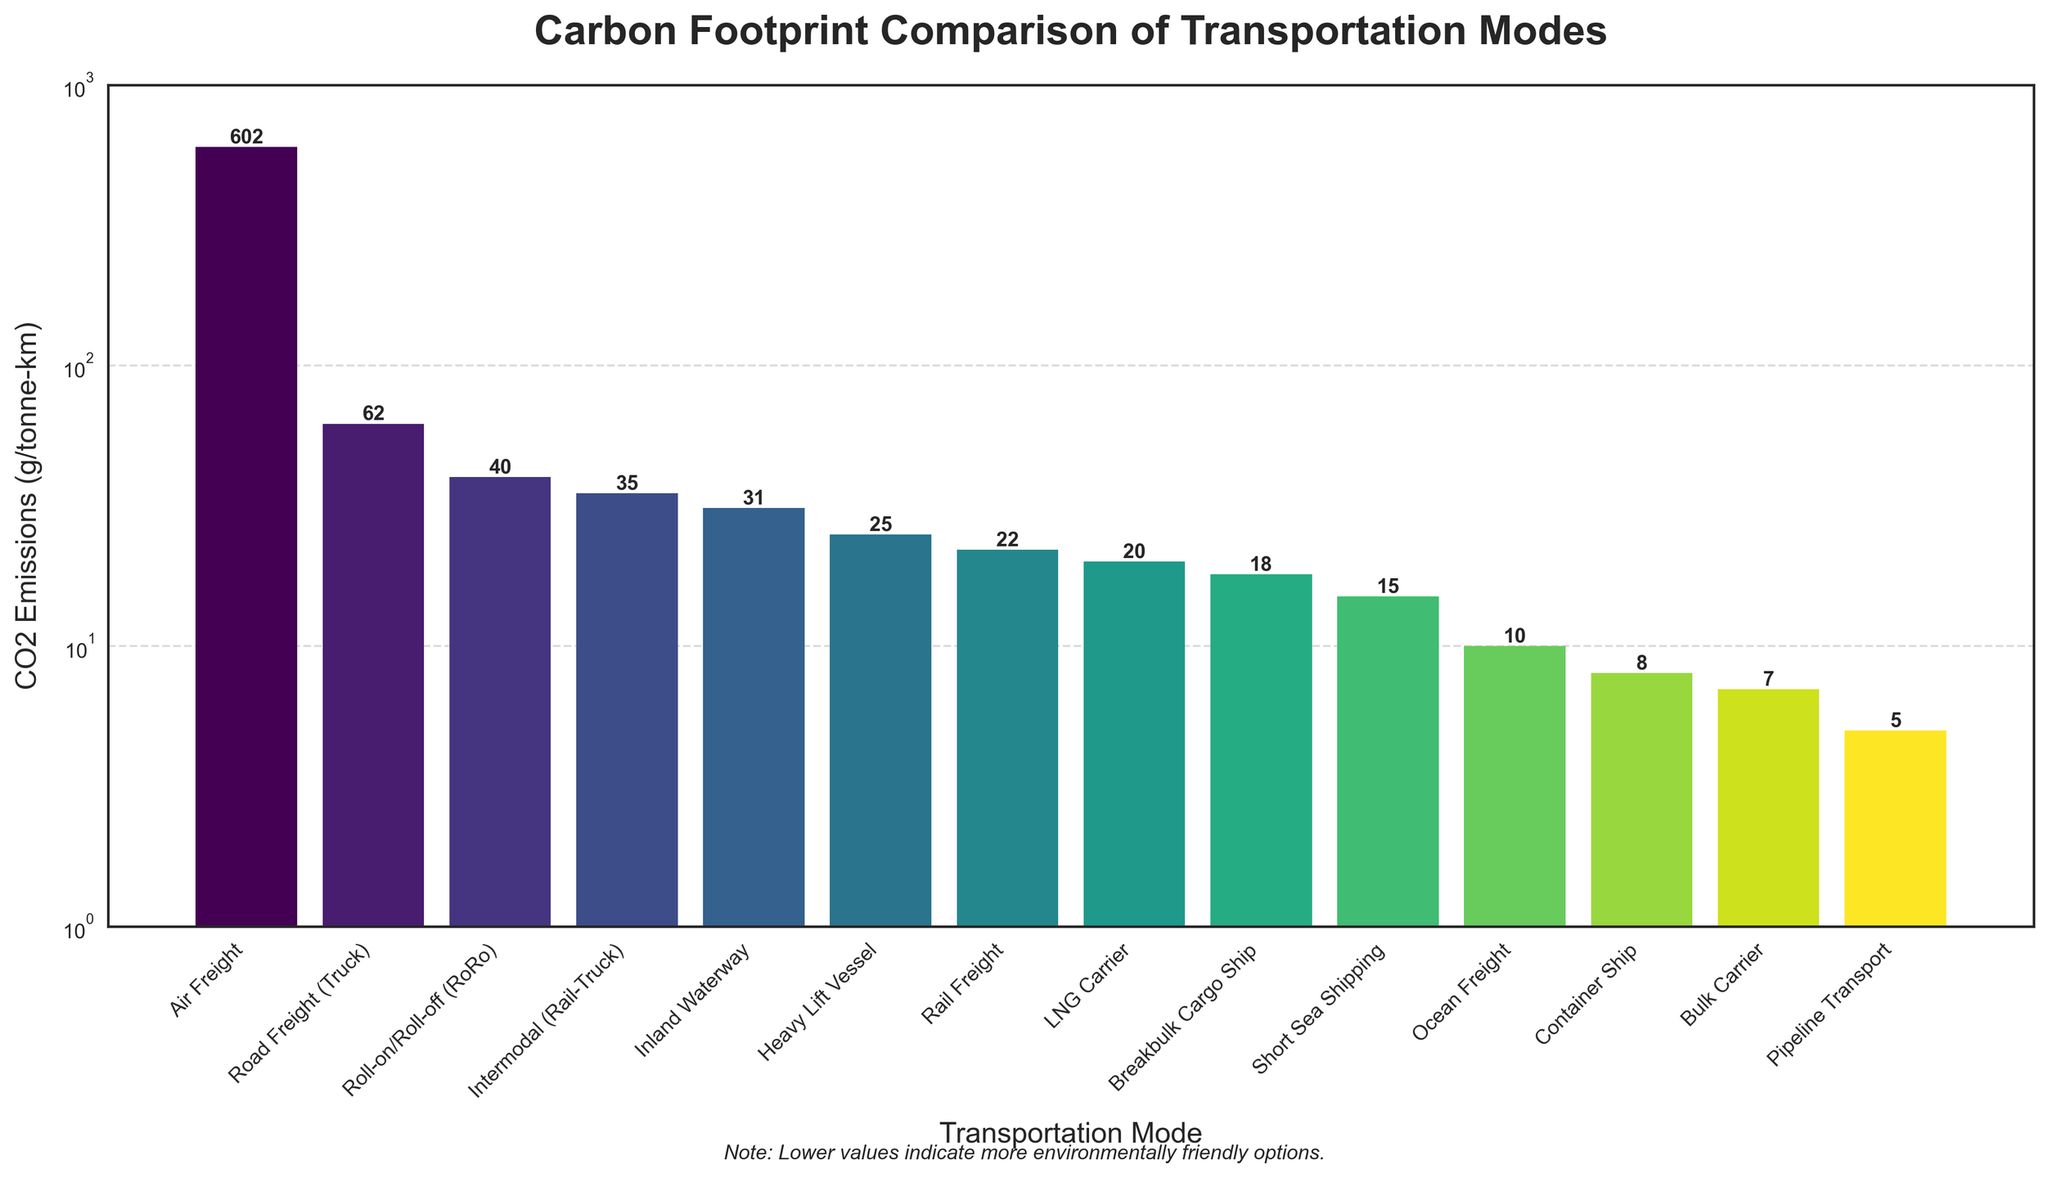Which transportation mode has the highest carbon footprint? The mode with the highest bar represents the transportation mode with the highest CO2 emissions. The highest bar is for Air Freight.
Answer: Air Freight Which transportation mode has the lowest carbon footprint? The mode with the lowest bar represents the transportation mode with the lowest CO2 emissions. The lowest bar is for Pipeline Transport.
Answer: Pipeline Transport How many transportation modes have CO2 emissions below 20 g/tonne-km? Count the number of bars with heights corresponding to CO2 emissions below 20. Ocean Freight, Pipeline Transport, Bulk Carrier, and Container Ship all have bars below 20.
Answer: Four What is the difference in CO2 emissions between Road Freight (Truck) and Short Sea Shipping? Find the heights of the bars for Road Freight (Truck) and Short Sea Shipping and subtract the latter from the former. Road Freight (Truck) is at 62 g/tonne-km and Short Sea Shipping is at 15 g/tonne-km. The difference is 62 - 15 = 47.
Answer: 47 Which has greater CO2 emissions: Intermodal (Rail-Truck) or Heavy Lift Vessel, and by how much? Look at the heights of their bars, then subtract the smaller value from the larger. Intermodal (Rail-Truck) has 35 g/tonne-km, and Heavy Lift Vessel has 25 g/tonne-km. 35 - 25 = 10.
Answer: Intermodal (Rail-Truck) by 10 What is the average CO2 emissions of Container Ship, Bulk Carrier, and LNG Carrier? Sum their values and divide by the number of modes. Container Ship: 8, Bulk Carrier: 7, LNG Carrier: 20. (8 + 7 + 20) / 3 = 35 / 3 ≈ 11.67.
Answer: 11.67 Is Inland Waterway more environmentally friendly than Roll-on/Roll-off (RoRo)? Compare the heights of the two bars. Inland Waterway is at 31 g/tonne-km, and RoRo is at 40 g/tonne-km. 31 < 40, so Inland Waterway is more environmentally friendly.
Answer: Yes Which mode has a carbon footprint exactly two times that of Breakbulk Cargo Ship? Find the emission value for Breakbulk Cargo Ship and multiply it by 2. Breakbulk Cargo Ship has 18 g/tonne-km. 18 x 2 = 36. The mode closest to this value is Intermodal (Rail-Truck) with 35 g/tonne-km.
Answer: Intermodal (Rail-Truck) What is the median CO2 emissions value of all transportation modes? List out the emissions values in ascending order to find the middle value. Sorted list: 5, 7, 8, 10, 15, 18, 20, 22, 25, 31, 35, 40, 62, 602. The median value is the average of the 7th and 8th values: (20 + 22) / 2 = 21.
Answer: 21 